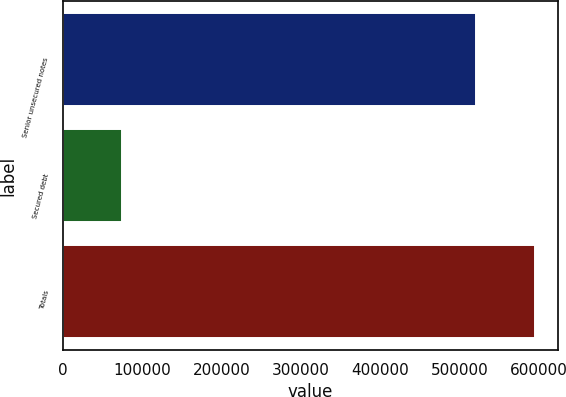Convert chart. <chart><loc_0><loc_0><loc_500><loc_500><bar_chart><fcel>Senior unsecured notes<fcel>Secured debt<fcel>Totals<nl><fcel>521203<fcel>73944<fcel>595147<nl></chart> 